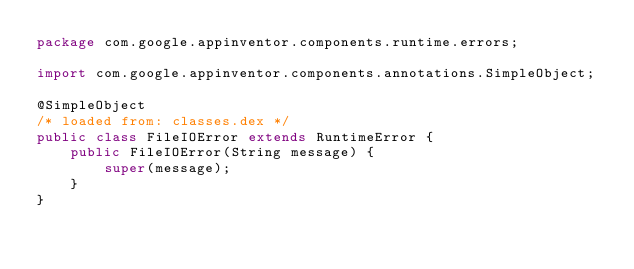<code> <loc_0><loc_0><loc_500><loc_500><_Java_>package com.google.appinventor.components.runtime.errors;

import com.google.appinventor.components.annotations.SimpleObject;

@SimpleObject
/* loaded from: classes.dex */
public class FileIOError extends RuntimeError {
    public FileIOError(String message) {
        super(message);
    }
}
</code> 